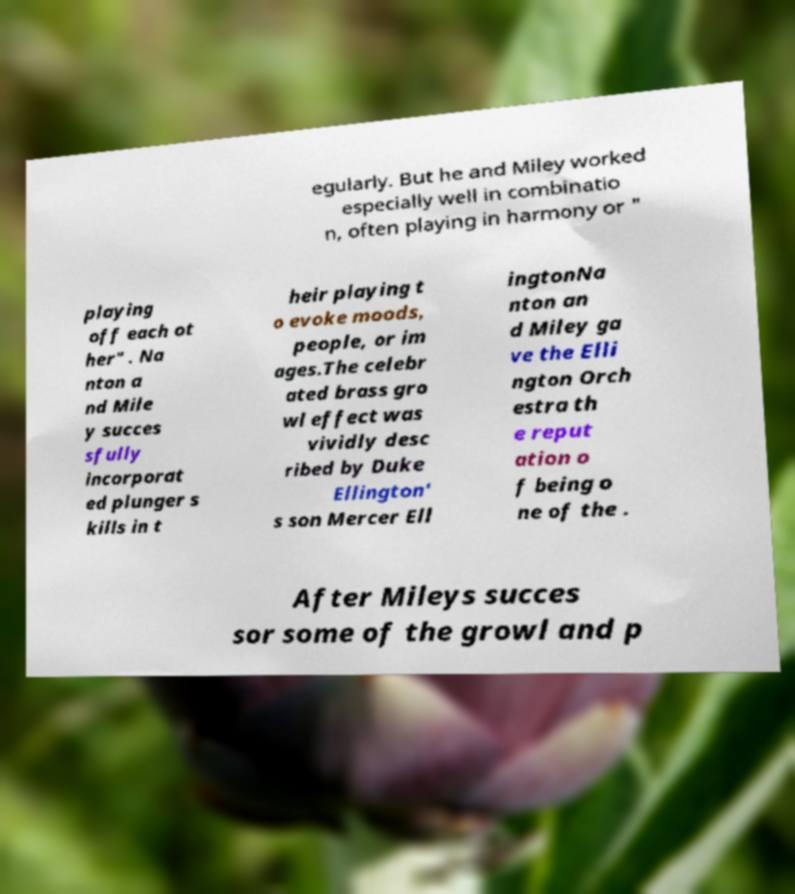I need the written content from this picture converted into text. Can you do that? egularly. But he and Miley worked especially well in combinatio n, often playing in harmony or " playing off each ot her" . Na nton a nd Mile y succes sfully incorporat ed plunger s kills in t heir playing t o evoke moods, people, or im ages.The celebr ated brass gro wl effect was vividly desc ribed by Duke Ellington' s son Mercer Ell ingtonNa nton an d Miley ga ve the Elli ngton Orch estra th e reput ation o f being o ne of the . After Mileys succes sor some of the growl and p 